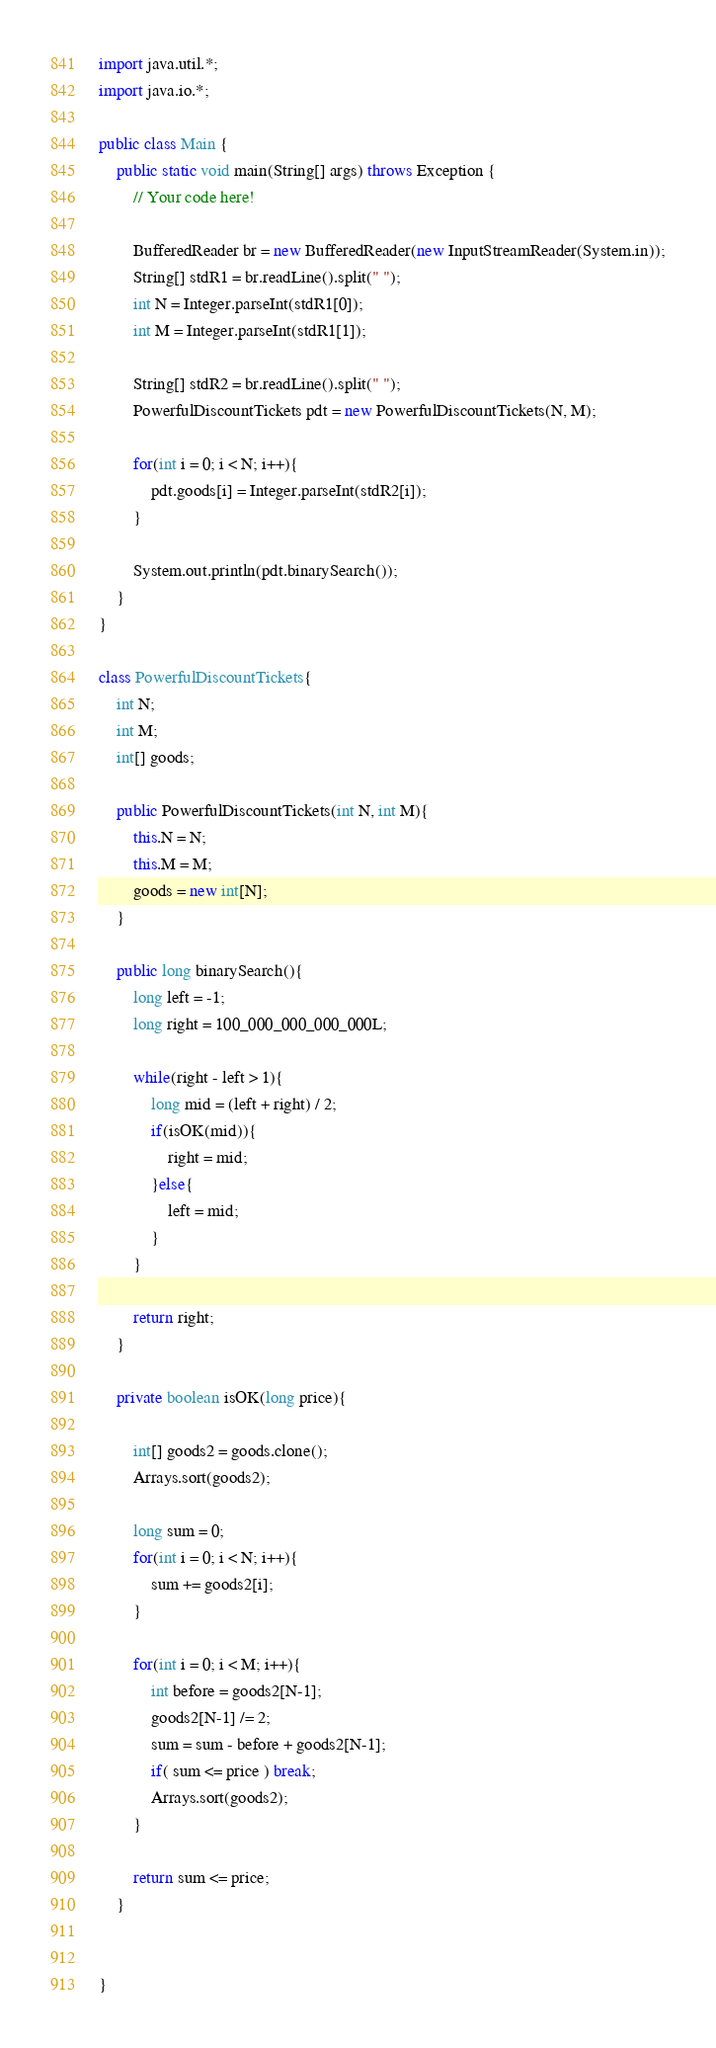Convert code to text. <code><loc_0><loc_0><loc_500><loc_500><_Java_>import java.util.*;
import java.io.*;

public class Main {
    public static void main(String[] args) throws Exception {
        // Your code here!
        
        BufferedReader br = new BufferedReader(new InputStreamReader(System.in));
        String[] stdR1 = br.readLine().split(" ");
        int N = Integer.parseInt(stdR1[0]);
        int M = Integer.parseInt(stdR1[1]);
        
        String[] stdR2 = br.readLine().split(" ");
        PowerfulDiscountTickets pdt = new PowerfulDiscountTickets(N, M);
        
        for(int i = 0; i < N; i++){
            pdt.goods[i] = Integer.parseInt(stdR2[i]);
        }
        
        System.out.println(pdt.binarySearch());
    }
}

class PowerfulDiscountTickets{
    int N;
    int M;
    int[] goods;
    
    public PowerfulDiscountTickets(int N, int M){
        this.N = N;
        this.M = M;
        goods = new int[N];
    }
    
    public long binarySearch(){
        long left = -1;
        long right = 100_000_000_000_000L;
        
        while(right - left > 1){
            long mid = (left + right) / 2;
            if(isOK(mid)){
                right = mid;
            }else{
                left = mid;
            }
        }
        
        return right;
    }
    
    private boolean isOK(long price){
        
        int[] goods2 = goods.clone();
        Arrays.sort(goods2);
        
        long sum = 0;
        for(int i = 0; i < N; i++){
            sum += goods2[i];
        }
        
        for(int i = 0; i < M; i++){
            int before = goods2[N-1];
            goods2[N-1] /= 2;
            sum = sum - before + goods2[N-1];
            if( sum <= price ) break;
            Arrays.sort(goods2);
        }
        
        return sum <= price;
    }
    

}


</code> 